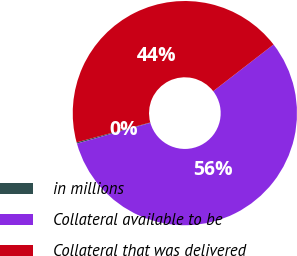Convert chart. <chart><loc_0><loc_0><loc_500><loc_500><pie_chart><fcel>in millions<fcel>Collateral available to be<fcel>Collateral that was delivered<nl><fcel>0.18%<fcel>56.1%<fcel>43.72%<nl></chart> 